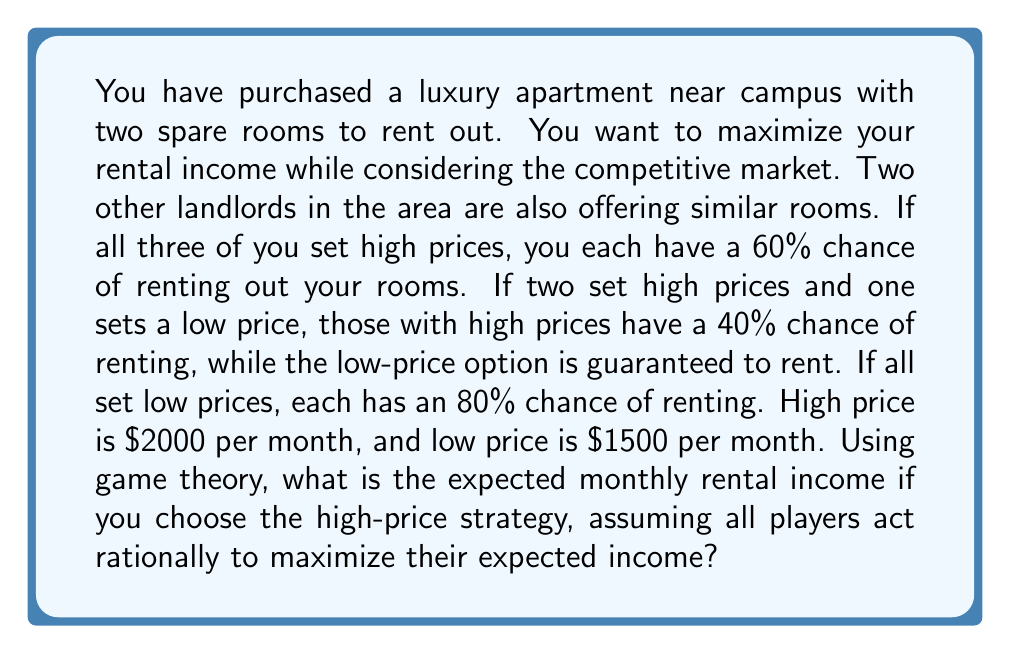What is the answer to this math problem? To solve this problem, we need to use game theory concepts and calculate the expected value for each strategy. Let's break it down step-by-step:

1) First, let's define the payoff matrix for this game. We'll calculate the expected income for each scenario:

   High price (H): $2000 per month
   Low price (L): $1500 per month

2) Possible scenarios and their probabilities:
   - All set high prices (HHH): 60% chance of renting
   - Two high, one low (HHL): 40% chance for high, 100% for low
   - All set low prices (LLL): 80% chance of renting

3) Expected income for each scenario:
   - HHH: $2000 * 0.60 = $1200
   - HHL (for high price): $2000 * 0.40 = $800
   - HHL (for low price): $1500 * 1.00 = $1500
   - LLL: $1500 * 0.80 = $1200

4) Now, let's analyze the game assuming all players act rationally. We need to find the Nash equilibrium.

5) If two players choose H, the third player's best response is L:
   $800 < $1500

6) If two players choose L, the third player's best response is also L:
   $800 < $1200

7) Therefore, the Nash equilibrium is for all players to choose L (LLL).

8) However, the question asks for the expected income if you choose the high-price strategy. In this case, we need to calculate the expected value assuming the other two players choose the low-price strategy (as that's the rational choice).

9) Your expected income with high price when others choose low:

   $$E(H|LL) = 2000 * 0.40 = 800$$
Answer: $800 per month 